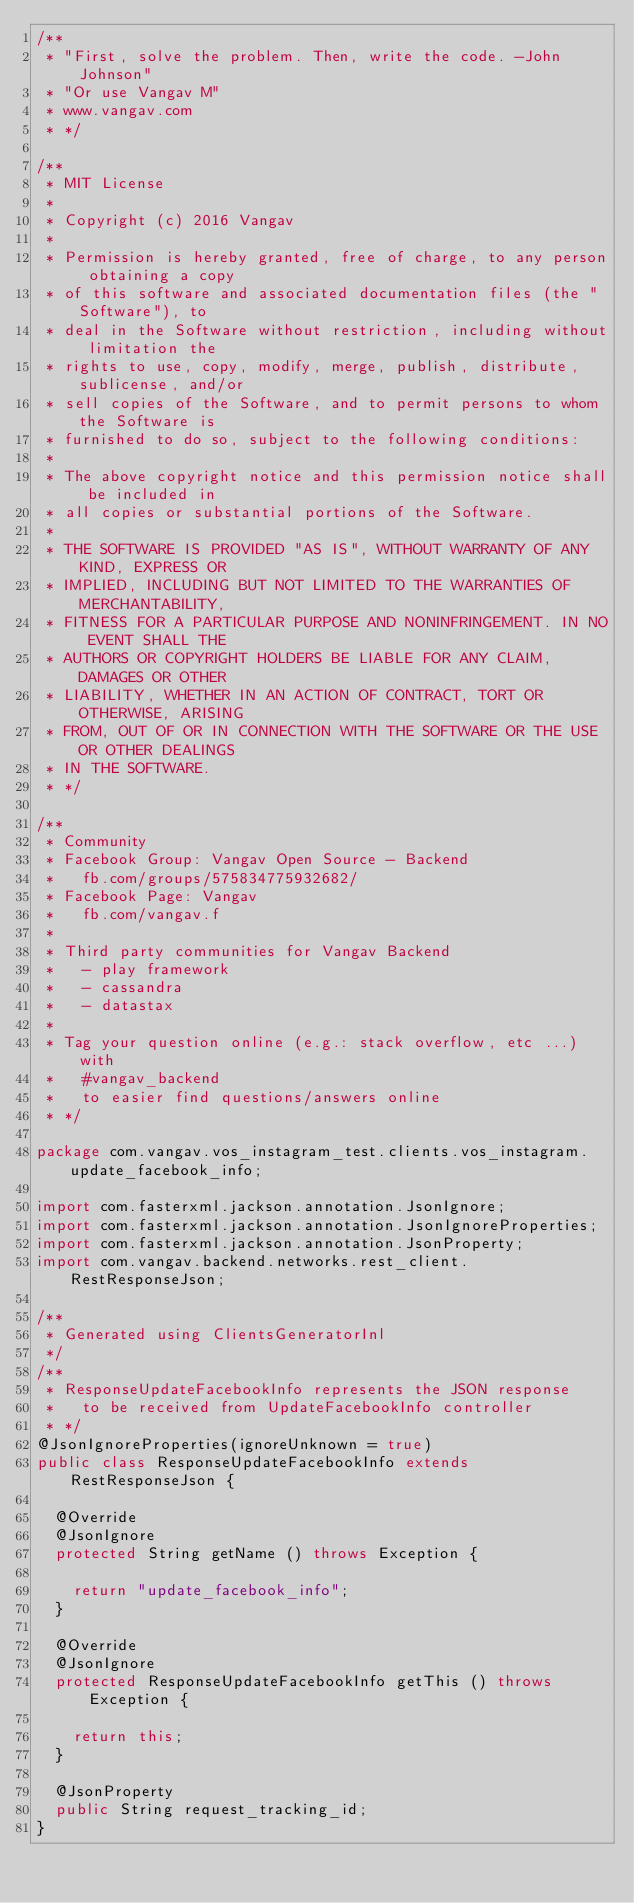Convert code to text. <code><loc_0><loc_0><loc_500><loc_500><_Java_>/**
 * "First, solve the problem. Then, write the code. -John Johnson"
 * "Or use Vangav M"
 * www.vangav.com
 * */

/**
 * MIT License
 *
 * Copyright (c) 2016 Vangav
 *
 * Permission is hereby granted, free of charge, to any person obtaining a copy
 * of this software and associated documentation files (the "Software"), to
 * deal in the Software without restriction, including without limitation the
 * rights to use, copy, modify, merge, publish, distribute, sublicense, and/or
 * sell copies of the Software, and to permit persons to whom the Software is
 * furnished to do so, subject to the following conditions:
 *
 * The above copyright notice and this permission notice shall be included in
 * all copies or substantial portions of the Software.
 *
 * THE SOFTWARE IS PROVIDED "AS IS", WITHOUT WARRANTY OF ANY KIND, EXPRESS OR
 * IMPLIED, INCLUDING BUT NOT LIMITED TO THE WARRANTIES OF MERCHANTABILITY,
 * FITNESS FOR A PARTICULAR PURPOSE AND NONINFRINGEMENT. IN NO EVENT SHALL THE
 * AUTHORS OR COPYRIGHT HOLDERS BE LIABLE FOR ANY CLAIM, DAMAGES OR OTHER
 * LIABILITY, WHETHER IN AN ACTION OF CONTRACT, TORT OR OTHERWISE, ARISING
 * FROM, OUT OF OR IN CONNECTION WITH THE SOFTWARE OR THE USE OR OTHER DEALINGS
 * IN THE SOFTWARE.
 * */

/**
 * Community
 * Facebook Group: Vangav Open Source - Backend
 *   fb.com/groups/575834775932682/
 * Facebook Page: Vangav
 *   fb.com/vangav.f
 * 
 * Third party communities for Vangav Backend
 *   - play framework
 *   - cassandra
 *   - datastax
 *   
 * Tag your question online (e.g.: stack overflow, etc ...) with
 *   #vangav_backend
 *   to easier find questions/answers online
 * */

package com.vangav.vos_instagram_test.clients.vos_instagram.update_facebook_info;

import com.fasterxml.jackson.annotation.JsonIgnore;
import com.fasterxml.jackson.annotation.JsonIgnoreProperties;
import com.fasterxml.jackson.annotation.JsonProperty;
import com.vangav.backend.networks.rest_client.RestResponseJson;

/**
 * Generated using ClientsGeneratorInl
 */
/**
 * ResponseUpdateFacebookInfo represents the JSON response
 *   to be received from UpdateFacebookInfo controller
 * */
@JsonIgnoreProperties(ignoreUnknown = true)
public class ResponseUpdateFacebookInfo extends RestResponseJson {

  @Override
  @JsonIgnore
  protected String getName () throws Exception {

    return "update_facebook_info";
  }

  @Override
  @JsonIgnore
  protected ResponseUpdateFacebookInfo getThis () throws Exception {

    return this;
  }

  @JsonProperty
  public String request_tracking_id;
}
</code> 